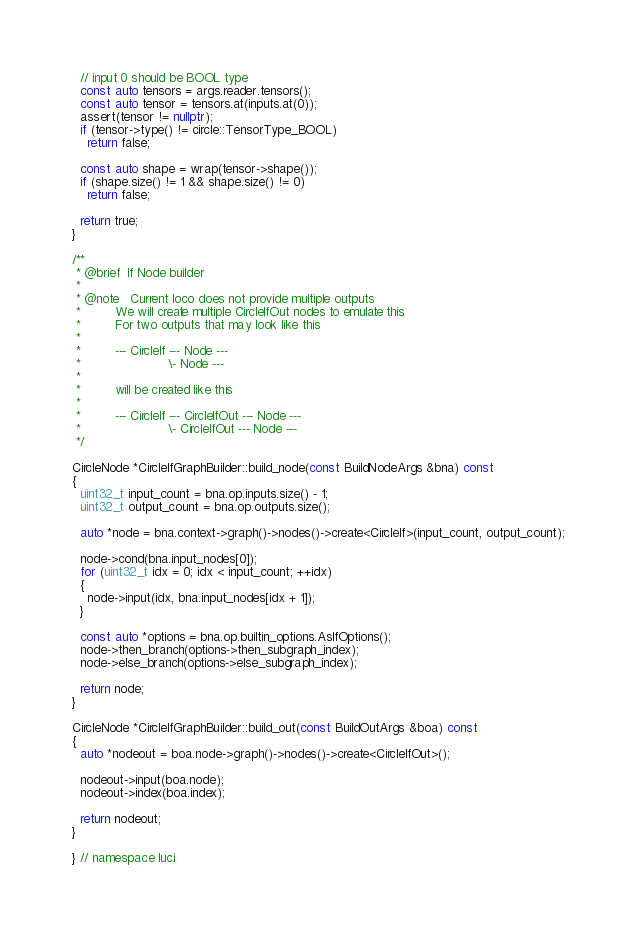<code> <loc_0><loc_0><loc_500><loc_500><_C++_>
  // input 0 should be BOOL type
  const auto tensors = args.reader.tensors();
  const auto tensor = tensors.at(inputs.at(0));
  assert(tensor != nullptr);
  if (tensor->type() != circle::TensorType_BOOL)
    return false;

  const auto shape = wrap(tensor->shape());
  if (shape.size() != 1 && shape.size() != 0)
    return false;

  return true;
}

/**
 * @brief  If Node builder
 *
 * @note   Current loco does not provide multiple outputs
 *         We will create multiple CircleIfOut nodes to emulate this
 *         For two outputs that may look like this
 *
 *         --- CircleIf --- Node ---
 *                       \- Node ---
 *
 *         will be created like this
 *
 *         --- CircleIf --- CircleIfOut --- Node ---
 *                       \- CircleIfOut --- Node ---
 */

CircleNode *CircleIfGraphBuilder::build_node(const BuildNodeArgs &bna) const
{
  uint32_t input_count = bna.op.inputs.size() - 1;
  uint32_t output_count = bna.op.outputs.size();

  auto *node = bna.context->graph()->nodes()->create<CircleIf>(input_count, output_count);

  node->cond(bna.input_nodes[0]);
  for (uint32_t idx = 0; idx < input_count; ++idx)
  {
    node->input(idx, bna.input_nodes[idx + 1]);
  }

  const auto *options = bna.op.builtin_options.AsIfOptions();
  node->then_branch(options->then_subgraph_index);
  node->else_branch(options->else_subgraph_index);

  return node;
}

CircleNode *CircleIfGraphBuilder::build_out(const BuildOutArgs &boa) const
{
  auto *nodeout = boa.node->graph()->nodes()->create<CircleIfOut>();

  nodeout->input(boa.node);
  nodeout->index(boa.index);

  return nodeout;
}

} // namespace luci
</code> 